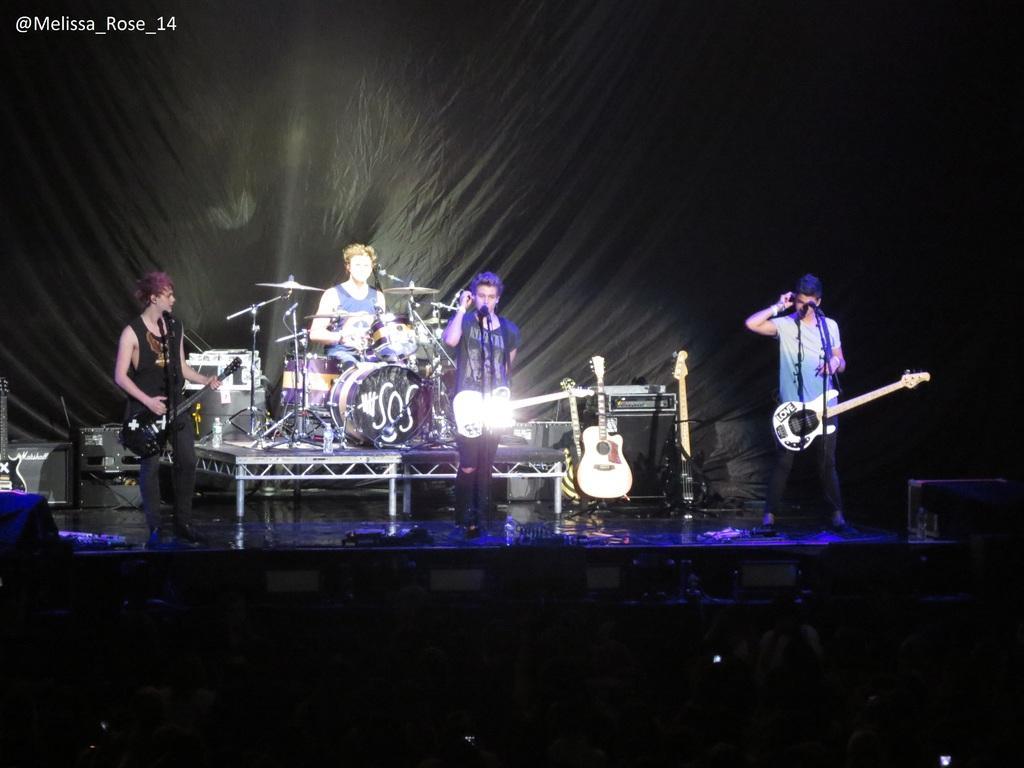Can you describe this image briefly? In this image we can see three people standing. They are wearing guitars. There is a man sitting and playing a band. There are speakers. In the background there is a curtain. There are guitars placed on the stand. 